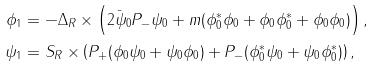<formula> <loc_0><loc_0><loc_500><loc_500>\phi _ { 1 } & = - \Delta _ { R } \times \left ( 2 \bar { \psi } _ { 0 } P _ { - } \psi _ { 0 } + m ( \phi _ { 0 } ^ { * } \phi _ { 0 } + \phi _ { 0 } \phi _ { 0 } ^ { * } + \phi _ { 0 } \phi _ { 0 } ) \right ) , \\ \psi _ { 1 } & = S _ { R } \times \left ( P _ { + } ( \phi _ { 0 } \psi _ { 0 } + \psi _ { 0 } \phi _ { 0 } ) + P _ { - } ( \phi _ { 0 } ^ { * } \psi _ { 0 } + \psi _ { 0 } \phi _ { 0 } ^ { * } ) \right ) ,</formula> 